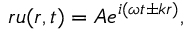Convert formula to latex. <formula><loc_0><loc_0><loc_500><loc_500>r u ( r , t ) = A e ^ { i ( \omega t \pm k r ) } ,</formula> 